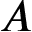Convert formula to latex. <formula><loc_0><loc_0><loc_500><loc_500>A</formula> 